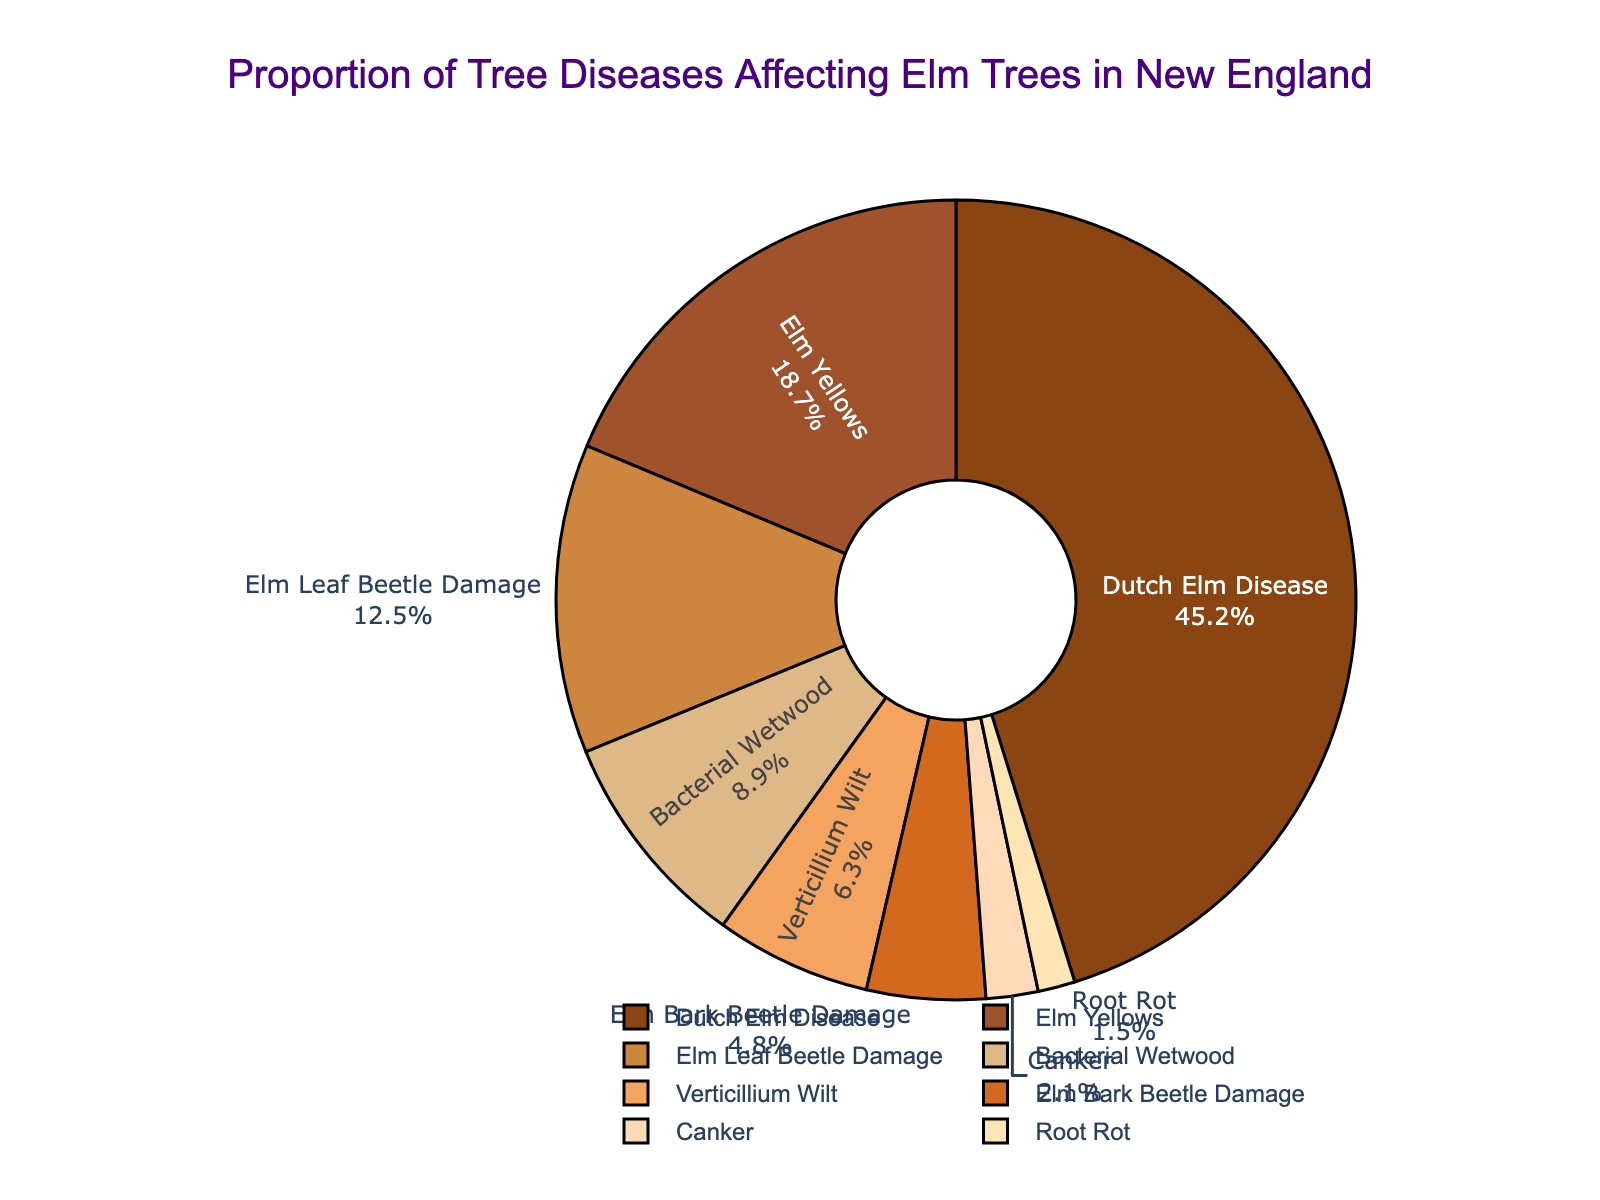What is the most common tree disease affecting elm trees in New England? The pie chart shows the proportions of different tree diseases. The largest segment represents Dutch Elm Disease. Therefore, Dutch Elm Disease is the most common tree disease.
Answer: Dutch Elm Disease What is the percentage of elm trees affected by Elm Leaf Beetle Damage? By referring to the labels in the pie chart, the segment representing Elm Leaf Beetle Damage is labeled as 12.5%.
Answer: 12.5% Which disease affects more elm trees: Elm Yellows or Verticillium Wilt? By comparing the pie chart segments, Elm Yellows has a larger proportion than Verticillium Wilt (18.7% vs. 6.3%). Therefore, Elm Yellows affects more elm trees.
Answer: Elm Yellows What is the combined percentage of elm trees affected by Bacterial Wetwood and Canker? Add the percentages of Bacterial Wetwood (8.9%) and Canker (2.1%). So, 8.9% + 2.1% = 11%.
Answer: 11% Does Elm Bark Beetle Damage represent a larger proportion of tree diseases than Root Rot? By examining the pie chart segments, Elm Bark Beetle Damage (4.8%) is larger than Root Rot (1.5%). Thus, Elm Bark Beetle Damage represents a larger proportion.
Answer: Yes How much more common is Dutch Elm Disease compared to Bacterial Wetwood? Find the difference between the percentages of Dutch Elm Disease (45.2%) and Bacterial Wetwood (8.9%). The difference is 45.2% - 8.9% = 36.3%.
Answer: 36.3% What is the least common tree disease affecting elm trees shown in the pie chart? The smallest segment in the pie chart represents Root Rot with a percentage of 1.5%.
Answer: Root Rot What is the total percentage of elm trees affected by Dutch Elm Disease, Elm Yellows, and Elm Leaf Beetle Damage combined? Sum the percentages of Dutch Elm Disease (45.2%), Elm Yellows (18.7%), and Elm Leaf Beetle Damage (12.5%). The total is 45.2% + 18.7% + 12.5% = 76.4%.
Answer: 76.4% Which tree disease represents a proportion closest to a tenth of the total percentage? Calculate 10% of 100%, which is 10%. Bacterial Wetwood, with a percentage of 8.9%, is the closest to 10%.
Answer: Bacterial Wetwood List the tree diseases affecting elm trees in New England that have a proportion less than 5%. From observing the pie chart, Elm Bark Beetle Damage (4.8%), Canker (2.1%), and Root Rot (1.5%) all have proportions less than 5%.
Answer: Elm Bark Beetle Damage, Canker, Root Rot 